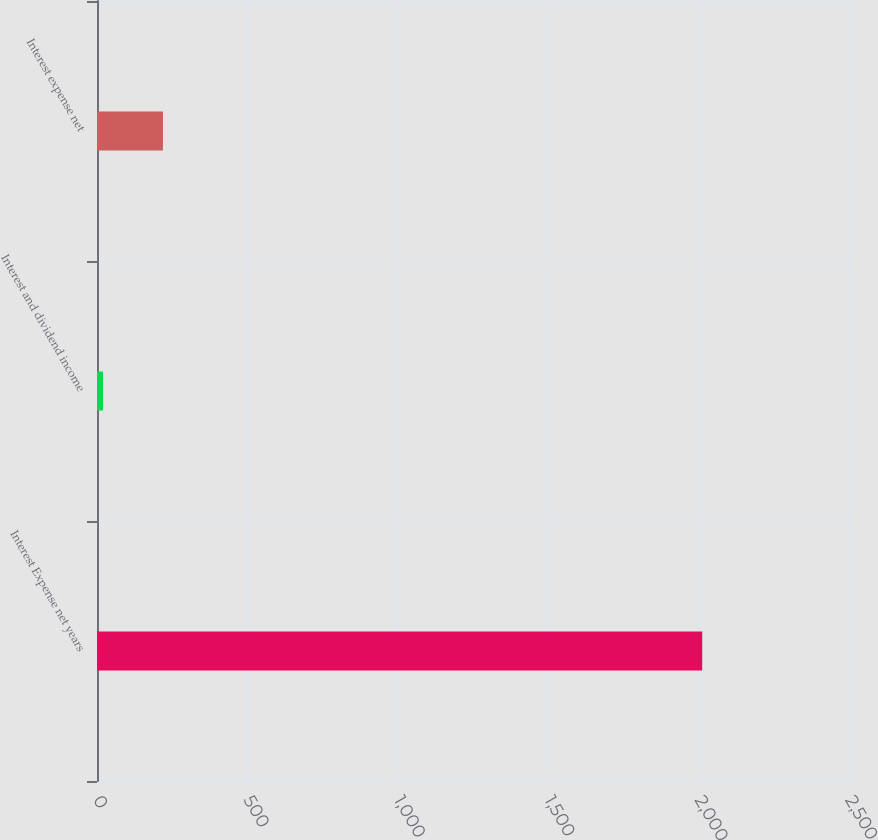<chart> <loc_0><loc_0><loc_500><loc_500><bar_chart><fcel>Interest Expense net years<fcel>Interest and dividend income<fcel>Interest expense net<nl><fcel>2012<fcel>20<fcel>219.2<nl></chart> 